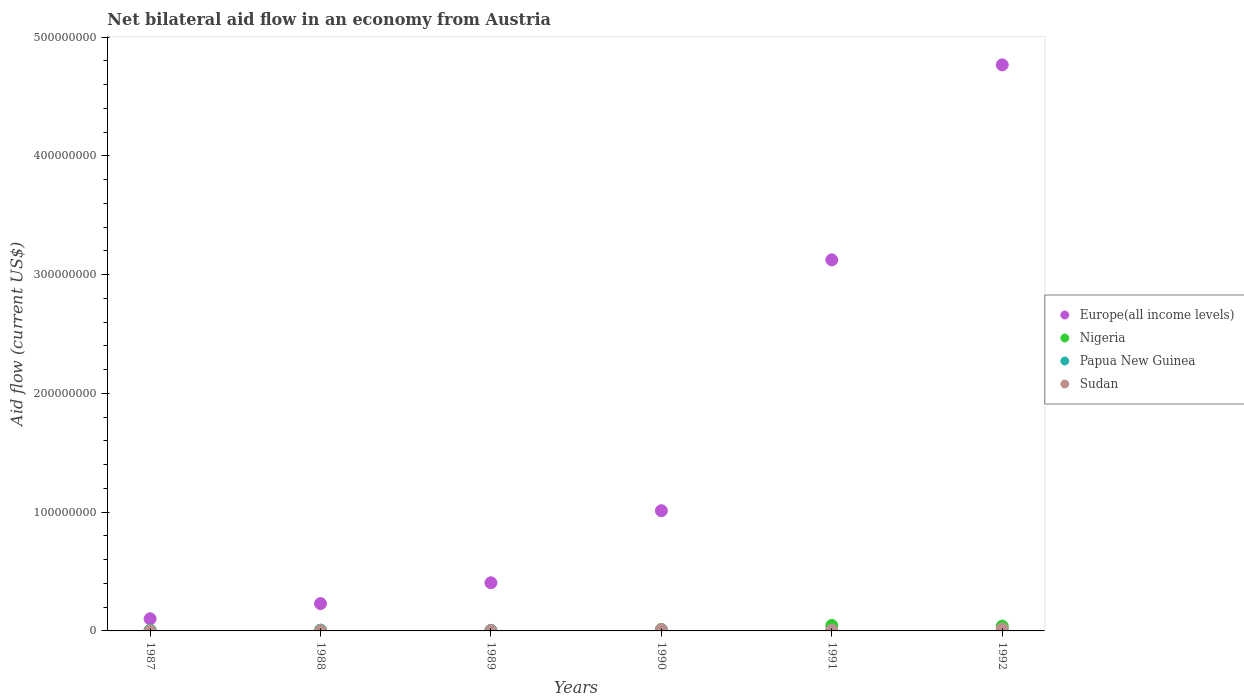How many different coloured dotlines are there?
Your answer should be very brief. 4. Is the number of dotlines equal to the number of legend labels?
Make the answer very short. Yes. What is the net bilateral aid flow in Nigeria in 1987?
Offer a terse response. 6.70e+05. Across all years, what is the maximum net bilateral aid flow in Europe(all income levels)?
Your answer should be very brief. 4.77e+08. Across all years, what is the minimum net bilateral aid flow in Papua New Guinea?
Your answer should be compact. 4.20e+05. In which year was the net bilateral aid flow in Papua New Guinea minimum?
Provide a short and direct response. 1991. What is the total net bilateral aid flow in Sudan in the graph?
Offer a terse response. 4.08e+06. What is the difference between the net bilateral aid flow in Europe(all income levels) in 1989 and the net bilateral aid flow in Nigeria in 1987?
Ensure brevity in your answer.  3.99e+07. What is the average net bilateral aid flow in Europe(all income levels) per year?
Keep it short and to the point. 1.61e+08. In the year 1990, what is the difference between the net bilateral aid flow in Sudan and net bilateral aid flow in Europe(all income levels)?
Your answer should be compact. -1.00e+08. In how many years, is the net bilateral aid flow in Europe(all income levels) greater than 340000000 US$?
Provide a short and direct response. 1. What is the ratio of the net bilateral aid flow in Sudan in 1987 to that in 1989?
Ensure brevity in your answer.  0.52. Is the net bilateral aid flow in Nigeria in 1991 less than that in 1992?
Offer a very short reply. No. Is the sum of the net bilateral aid flow in Nigeria in 1988 and 1992 greater than the maximum net bilateral aid flow in Papua New Guinea across all years?
Offer a terse response. Yes. Is it the case that in every year, the sum of the net bilateral aid flow in Sudan and net bilateral aid flow in Europe(all income levels)  is greater than the net bilateral aid flow in Nigeria?
Provide a succinct answer. Yes. Is the net bilateral aid flow in Europe(all income levels) strictly greater than the net bilateral aid flow in Nigeria over the years?
Your response must be concise. Yes. Is the net bilateral aid flow in Europe(all income levels) strictly less than the net bilateral aid flow in Papua New Guinea over the years?
Your answer should be compact. No. What is the difference between two consecutive major ticks on the Y-axis?
Provide a short and direct response. 1.00e+08. Are the values on the major ticks of Y-axis written in scientific E-notation?
Offer a terse response. No. Does the graph contain grids?
Offer a terse response. No. How many legend labels are there?
Make the answer very short. 4. What is the title of the graph?
Offer a terse response. Net bilateral aid flow in an economy from Austria. Does "Bermuda" appear as one of the legend labels in the graph?
Offer a terse response. No. What is the label or title of the X-axis?
Offer a terse response. Years. What is the label or title of the Y-axis?
Offer a very short reply. Aid flow (current US$). What is the Aid flow (current US$) in Europe(all income levels) in 1987?
Your response must be concise. 1.02e+07. What is the Aid flow (current US$) of Nigeria in 1987?
Keep it short and to the point. 6.70e+05. What is the Aid flow (current US$) in Papua New Guinea in 1987?
Offer a very short reply. 6.40e+05. What is the Aid flow (current US$) of Europe(all income levels) in 1988?
Your answer should be compact. 2.30e+07. What is the Aid flow (current US$) of Papua New Guinea in 1988?
Ensure brevity in your answer.  5.40e+05. What is the Aid flow (current US$) of Europe(all income levels) in 1989?
Your answer should be compact. 4.05e+07. What is the Aid flow (current US$) in Papua New Guinea in 1989?
Give a very brief answer. 5.20e+05. What is the Aid flow (current US$) of Europe(all income levels) in 1990?
Your answer should be very brief. 1.01e+08. What is the Aid flow (current US$) in Nigeria in 1990?
Provide a succinct answer. 1.24e+06. What is the Aid flow (current US$) of Papua New Guinea in 1990?
Keep it short and to the point. 5.70e+05. What is the Aid flow (current US$) in Sudan in 1990?
Offer a terse response. 1.15e+06. What is the Aid flow (current US$) in Europe(all income levels) in 1991?
Offer a very short reply. 3.12e+08. What is the Aid flow (current US$) of Nigeria in 1991?
Your response must be concise. 4.63e+06. What is the Aid flow (current US$) of Europe(all income levels) in 1992?
Make the answer very short. 4.77e+08. What is the Aid flow (current US$) in Nigeria in 1992?
Make the answer very short. 4.07e+06. What is the Aid flow (current US$) of Papua New Guinea in 1992?
Ensure brevity in your answer.  5.40e+05. What is the Aid flow (current US$) of Sudan in 1992?
Keep it short and to the point. 1.61e+06. Across all years, what is the maximum Aid flow (current US$) in Europe(all income levels)?
Give a very brief answer. 4.77e+08. Across all years, what is the maximum Aid flow (current US$) in Nigeria?
Your response must be concise. 4.63e+06. Across all years, what is the maximum Aid flow (current US$) of Papua New Guinea?
Your answer should be compact. 6.40e+05. Across all years, what is the maximum Aid flow (current US$) of Sudan?
Offer a very short reply. 1.61e+06. Across all years, what is the minimum Aid flow (current US$) in Europe(all income levels)?
Ensure brevity in your answer.  1.02e+07. What is the total Aid flow (current US$) of Europe(all income levels) in the graph?
Make the answer very short. 9.64e+08. What is the total Aid flow (current US$) of Nigeria in the graph?
Your answer should be very brief. 1.15e+07. What is the total Aid flow (current US$) in Papua New Guinea in the graph?
Make the answer very short. 3.23e+06. What is the total Aid flow (current US$) of Sudan in the graph?
Make the answer very short. 4.08e+06. What is the difference between the Aid flow (current US$) in Europe(all income levels) in 1987 and that in 1988?
Offer a terse response. -1.28e+07. What is the difference between the Aid flow (current US$) in Nigeria in 1987 and that in 1988?
Your response must be concise. 10000. What is the difference between the Aid flow (current US$) in Papua New Guinea in 1987 and that in 1988?
Your response must be concise. 1.00e+05. What is the difference between the Aid flow (current US$) in Europe(all income levels) in 1987 and that in 1989?
Make the answer very short. -3.03e+07. What is the difference between the Aid flow (current US$) of Sudan in 1987 and that in 1989?
Provide a succinct answer. -1.50e+05. What is the difference between the Aid flow (current US$) in Europe(all income levels) in 1987 and that in 1990?
Provide a succinct answer. -9.10e+07. What is the difference between the Aid flow (current US$) of Nigeria in 1987 and that in 1990?
Your answer should be very brief. -5.70e+05. What is the difference between the Aid flow (current US$) in Papua New Guinea in 1987 and that in 1990?
Ensure brevity in your answer.  7.00e+04. What is the difference between the Aid flow (current US$) in Sudan in 1987 and that in 1990?
Provide a succinct answer. -9.90e+05. What is the difference between the Aid flow (current US$) in Europe(all income levels) in 1987 and that in 1991?
Provide a short and direct response. -3.02e+08. What is the difference between the Aid flow (current US$) of Nigeria in 1987 and that in 1991?
Keep it short and to the point. -3.96e+06. What is the difference between the Aid flow (current US$) of Sudan in 1987 and that in 1991?
Give a very brief answer. -4.40e+05. What is the difference between the Aid flow (current US$) in Europe(all income levels) in 1987 and that in 1992?
Provide a short and direct response. -4.66e+08. What is the difference between the Aid flow (current US$) of Nigeria in 1987 and that in 1992?
Your answer should be very brief. -3.40e+06. What is the difference between the Aid flow (current US$) in Papua New Guinea in 1987 and that in 1992?
Provide a short and direct response. 1.00e+05. What is the difference between the Aid flow (current US$) of Sudan in 1987 and that in 1992?
Offer a very short reply. -1.45e+06. What is the difference between the Aid flow (current US$) of Europe(all income levels) in 1988 and that in 1989?
Your answer should be very brief. -1.75e+07. What is the difference between the Aid flow (current US$) of Nigeria in 1988 and that in 1989?
Keep it short and to the point. 4.10e+05. What is the difference between the Aid flow (current US$) of Papua New Guinea in 1988 and that in 1989?
Your answer should be compact. 2.00e+04. What is the difference between the Aid flow (current US$) of Sudan in 1988 and that in 1989?
Make the answer very short. -6.00e+04. What is the difference between the Aid flow (current US$) of Europe(all income levels) in 1988 and that in 1990?
Your answer should be very brief. -7.82e+07. What is the difference between the Aid flow (current US$) of Nigeria in 1988 and that in 1990?
Give a very brief answer. -5.80e+05. What is the difference between the Aid flow (current US$) of Sudan in 1988 and that in 1990?
Your response must be concise. -9.00e+05. What is the difference between the Aid flow (current US$) of Europe(all income levels) in 1988 and that in 1991?
Provide a succinct answer. -2.89e+08. What is the difference between the Aid flow (current US$) in Nigeria in 1988 and that in 1991?
Offer a terse response. -3.97e+06. What is the difference between the Aid flow (current US$) in Sudan in 1988 and that in 1991?
Your response must be concise. -3.50e+05. What is the difference between the Aid flow (current US$) in Europe(all income levels) in 1988 and that in 1992?
Ensure brevity in your answer.  -4.54e+08. What is the difference between the Aid flow (current US$) in Nigeria in 1988 and that in 1992?
Provide a short and direct response. -3.41e+06. What is the difference between the Aid flow (current US$) of Papua New Guinea in 1988 and that in 1992?
Make the answer very short. 0. What is the difference between the Aid flow (current US$) in Sudan in 1988 and that in 1992?
Your response must be concise. -1.36e+06. What is the difference between the Aid flow (current US$) in Europe(all income levels) in 1989 and that in 1990?
Ensure brevity in your answer.  -6.07e+07. What is the difference between the Aid flow (current US$) in Nigeria in 1989 and that in 1990?
Offer a terse response. -9.90e+05. What is the difference between the Aid flow (current US$) of Sudan in 1989 and that in 1990?
Offer a terse response. -8.40e+05. What is the difference between the Aid flow (current US$) of Europe(all income levels) in 1989 and that in 1991?
Make the answer very short. -2.72e+08. What is the difference between the Aid flow (current US$) in Nigeria in 1989 and that in 1991?
Give a very brief answer. -4.38e+06. What is the difference between the Aid flow (current US$) of Europe(all income levels) in 1989 and that in 1992?
Your response must be concise. -4.36e+08. What is the difference between the Aid flow (current US$) of Nigeria in 1989 and that in 1992?
Give a very brief answer. -3.82e+06. What is the difference between the Aid flow (current US$) in Papua New Guinea in 1989 and that in 1992?
Keep it short and to the point. -2.00e+04. What is the difference between the Aid flow (current US$) of Sudan in 1989 and that in 1992?
Give a very brief answer. -1.30e+06. What is the difference between the Aid flow (current US$) of Europe(all income levels) in 1990 and that in 1991?
Keep it short and to the point. -2.11e+08. What is the difference between the Aid flow (current US$) of Nigeria in 1990 and that in 1991?
Provide a short and direct response. -3.39e+06. What is the difference between the Aid flow (current US$) in Papua New Guinea in 1990 and that in 1991?
Offer a terse response. 1.50e+05. What is the difference between the Aid flow (current US$) of Europe(all income levels) in 1990 and that in 1992?
Make the answer very short. -3.75e+08. What is the difference between the Aid flow (current US$) in Nigeria in 1990 and that in 1992?
Your response must be concise. -2.83e+06. What is the difference between the Aid flow (current US$) of Sudan in 1990 and that in 1992?
Your answer should be very brief. -4.60e+05. What is the difference between the Aid flow (current US$) in Europe(all income levels) in 1991 and that in 1992?
Give a very brief answer. -1.64e+08. What is the difference between the Aid flow (current US$) of Nigeria in 1991 and that in 1992?
Provide a succinct answer. 5.60e+05. What is the difference between the Aid flow (current US$) of Papua New Guinea in 1991 and that in 1992?
Give a very brief answer. -1.20e+05. What is the difference between the Aid flow (current US$) in Sudan in 1991 and that in 1992?
Ensure brevity in your answer.  -1.01e+06. What is the difference between the Aid flow (current US$) in Europe(all income levels) in 1987 and the Aid flow (current US$) in Nigeria in 1988?
Give a very brief answer. 9.56e+06. What is the difference between the Aid flow (current US$) of Europe(all income levels) in 1987 and the Aid flow (current US$) of Papua New Guinea in 1988?
Provide a short and direct response. 9.68e+06. What is the difference between the Aid flow (current US$) in Europe(all income levels) in 1987 and the Aid flow (current US$) in Sudan in 1988?
Your answer should be compact. 9.97e+06. What is the difference between the Aid flow (current US$) of Nigeria in 1987 and the Aid flow (current US$) of Papua New Guinea in 1988?
Provide a succinct answer. 1.30e+05. What is the difference between the Aid flow (current US$) of Papua New Guinea in 1987 and the Aid flow (current US$) of Sudan in 1988?
Provide a succinct answer. 3.90e+05. What is the difference between the Aid flow (current US$) of Europe(all income levels) in 1987 and the Aid flow (current US$) of Nigeria in 1989?
Offer a very short reply. 9.97e+06. What is the difference between the Aid flow (current US$) in Europe(all income levels) in 1987 and the Aid flow (current US$) in Papua New Guinea in 1989?
Your answer should be very brief. 9.70e+06. What is the difference between the Aid flow (current US$) of Europe(all income levels) in 1987 and the Aid flow (current US$) of Sudan in 1989?
Provide a short and direct response. 9.91e+06. What is the difference between the Aid flow (current US$) in Nigeria in 1987 and the Aid flow (current US$) in Papua New Guinea in 1989?
Your response must be concise. 1.50e+05. What is the difference between the Aid flow (current US$) of Europe(all income levels) in 1987 and the Aid flow (current US$) of Nigeria in 1990?
Make the answer very short. 8.98e+06. What is the difference between the Aid flow (current US$) in Europe(all income levels) in 1987 and the Aid flow (current US$) in Papua New Guinea in 1990?
Offer a very short reply. 9.65e+06. What is the difference between the Aid flow (current US$) in Europe(all income levels) in 1987 and the Aid flow (current US$) in Sudan in 1990?
Make the answer very short. 9.07e+06. What is the difference between the Aid flow (current US$) in Nigeria in 1987 and the Aid flow (current US$) in Papua New Guinea in 1990?
Your answer should be very brief. 1.00e+05. What is the difference between the Aid flow (current US$) in Nigeria in 1987 and the Aid flow (current US$) in Sudan in 1990?
Make the answer very short. -4.80e+05. What is the difference between the Aid flow (current US$) in Papua New Guinea in 1987 and the Aid flow (current US$) in Sudan in 1990?
Offer a terse response. -5.10e+05. What is the difference between the Aid flow (current US$) of Europe(all income levels) in 1987 and the Aid flow (current US$) of Nigeria in 1991?
Provide a short and direct response. 5.59e+06. What is the difference between the Aid flow (current US$) in Europe(all income levels) in 1987 and the Aid flow (current US$) in Papua New Guinea in 1991?
Provide a succinct answer. 9.80e+06. What is the difference between the Aid flow (current US$) of Europe(all income levels) in 1987 and the Aid flow (current US$) of Sudan in 1991?
Give a very brief answer. 9.62e+06. What is the difference between the Aid flow (current US$) in Nigeria in 1987 and the Aid flow (current US$) in Papua New Guinea in 1991?
Your answer should be compact. 2.50e+05. What is the difference between the Aid flow (current US$) in Papua New Guinea in 1987 and the Aid flow (current US$) in Sudan in 1991?
Ensure brevity in your answer.  4.00e+04. What is the difference between the Aid flow (current US$) of Europe(all income levels) in 1987 and the Aid flow (current US$) of Nigeria in 1992?
Provide a short and direct response. 6.15e+06. What is the difference between the Aid flow (current US$) of Europe(all income levels) in 1987 and the Aid flow (current US$) of Papua New Guinea in 1992?
Give a very brief answer. 9.68e+06. What is the difference between the Aid flow (current US$) in Europe(all income levels) in 1987 and the Aid flow (current US$) in Sudan in 1992?
Provide a short and direct response. 8.61e+06. What is the difference between the Aid flow (current US$) in Nigeria in 1987 and the Aid flow (current US$) in Sudan in 1992?
Offer a terse response. -9.40e+05. What is the difference between the Aid flow (current US$) of Papua New Guinea in 1987 and the Aid flow (current US$) of Sudan in 1992?
Ensure brevity in your answer.  -9.70e+05. What is the difference between the Aid flow (current US$) in Europe(all income levels) in 1988 and the Aid flow (current US$) in Nigeria in 1989?
Keep it short and to the point. 2.28e+07. What is the difference between the Aid flow (current US$) of Europe(all income levels) in 1988 and the Aid flow (current US$) of Papua New Guinea in 1989?
Your answer should be compact. 2.25e+07. What is the difference between the Aid flow (current US$) of Europe(all income levels) in 1988 and the Aid flow (current US$) of Sudan in 1989?
Give a very brief answer. 2.27e+07. What is the difference between the Aid flow (current US$) in Europe(all income levels) in 1988 and the Aid flow (current US$) in Nigeria in 1990?
Make the answer very short. 2.18e+07. What is the difference between the Aid flow (current US$) of Europe(all income levels) in 1988 and the Aid flow (current US$) of Papua New Guinea in 1990?
Keep it short and to the point. 2.24e+07. What is the difference between the Aid flow (current US$) in Europe(all income levels) in 1988 and the Aid flow (current US$) in Sudan in 1990?
Offer a very short reply. 2.19e+07. What is the difference between the Aid flow (current US$) in Nigeria in 1988 and the Aid flow (current US$) in Sudan in 1990?
Your answer should be very brief. -4.90e+05. What is the difference between the Aid flow (current US$) of Papua New Guinea in 1988 and the Aid flow (current US$) of Sudan in 1990?
Make the answer very short. -6.10e+05. What is the difference between the Aid flow (current US$) in Europe(all income levels) in 1988 and the Aid flow (current US$) in Nigeria in 1991?
Keep it short and to the point. 1.84e+07. What is the difference between the Aid flow (current US$) in Europe(all income levels) in 1988 and the Aid flow (current US$) in Papua New Guinea in 1991?
Provide a short and direct response. 2.26e+07. What is the difference between the Aid flow (current US$) in Europe(all income levels) in 1988 and the Aid flow (current US$) in Sudan in 1991?
Ensure brevity in your answer.  2.24e+07. What is the difference between the Aid flow (current US$) of Nigeria in 1988 and the Aid flow (current US$) of Papua New Guinea in 1991?
Keep it short and to the point. 2.40e+05. What is the difference between the Aid flow (current US$) in Europe(all income levels) in 1988 and the Aid flow (current US$) in Nigeria in 1992?
Make the answer very short. 1.89e+07. What is the difference between the Aid flow (current US$) of Europe(all income levels) in 1988 and the Aid flow (current US$) of Papua New Guinea in 1992?
Your answer should be compact. 2.25e+07. What is the difference between the Aid flow (current US$) in Europe(all income levels) in 1988 and the Aid flow (current US$) in Sudan in 1992?
Your answer should be compact. 2.14e+07. What is the difference between the Aid flow (current US$) of Nigeria in 1988 and the Aid flow (current US$) of Sudan in 1992?
Make the answer very short. -9.50e+05. What is the difference between the Aid flow (current US$) in Papua New Guinea in 1988 and the Aid flow (current US$) in Sudan in 1992?
Make the answer very short. -1.07e+06. What is the difference between the Aid flow (current US$) of Europe(all income levels) in 1989 and the Aid flow (current US$) of Nigeria in 1990?
Offer a very short reply. 3.93e+07. What is the difference between the Aid flow (current US$) of Europe(all income levels) in 1989 and the Aid flow (current US$) of Papua New Guinea in 1990?
Offer a terse response. 4.00e+07. What is the difference between the Aid flow (current US$) of Europe(all income levels) in 1989 and the Aid flow (current US$) of Sudan in 1990?
Offer a very short reply. 3.94e+07. What is the difference between the Aid flow (current US$) in Nigeria in 1989 and the Aid flow (current US$) in Papua New Guinea in 1990?
Offer a very short reply. -3.20e+05. What is the difference between the Aid flow (current US$) in Nigeria in 1989 and the Aid flow (current US$) in Sudan in 1990?
Your answer should be compact. -9.00e+05. What is the difference between the Aid flow (current US$) in Papua New Guinea in 1989 and the Aid flow (current US$) in Sudan in 1990?
Keep it short and to the point. -6.30e+05. What is the difference between the Aid flow (current US$) of Europe(all income levels) in 1989 and the Aid flow (current US$) of Nigeria in 1991?
Your answer should be compact. 3.59e+07. What is the difference between the Aid flow (current US$) of Europe(all income levels) in 1989 and the Aid flow (current US$) of Papua New Guinea in 1991?
Offer a terse response. 4.01e+07. What is the difference between the Aid flow (current US$) of Europe(all income levels) in 1989 and the Aid flow (current US$) of Sudan in 1991?
Your response must be concise. 3.99e+07. What is the difference between the Aid flow (current US$) of Nigeria in 1989 and the Aid flow (current US$) of Sudan in 1991?
Make the answer very short. -3.50e+05. What is the difference between the Aid flow (current US$) in Papua New Guinea in 1989 and the Aid flow (current US$) in Sudan in 1991?
Offer a very short reply. -8.00e+04. What is the difference between the Aid flow (current US$) in Europe(all income levels) in 1989 and the Aid flow (current US$) in Nigeria in 1992?
Provide a short and direct response. 3.65e+07. What is the difference between the Aid flow (current US$) in Europe(all income levels) in 1989 and the Aid flow (current US$) in Papua New Guinea in 1992?
Keep it short and to the point. 4.00e+07. What is the difference between the Aid flow (current US$) in Europe(all income levels) in 1989 and the Aid flow (current US$) in Sudan in 1992?
Your response must be concise. 3.89e+07. What is the difference between the Aid flow (current US$) of Nigeria in 1989 and the Aid flow (current US$) of Sudan in 1992?
Offer a very short reply. -1.36e+06. What is the difference between the Aid flow (current US$) in Papua New Guinea in 1989 and the Aid flow (current US$) in Sudan in 1992?
Offer a very short reply. -1.09e+06. What is the difference between the Aid flow (current US$) of Europe(all income levels) in 1990 and the Aid flow (current US$) of Nigeria in 1991?
Provide a short and direct response. 9.66e+07. What is the difference between the Aid flow (current US$) in Europe(all income levels) in 1990 and the Aid flow (current US$) in Papua New Guinea in 1991?
Your response must be concise. 1.01e+08. What is the difference between the Aid flow (current US$) of Europe(all income levels) in 1990 and the Aid flow (current US$) of Sudan in 1991?
Your answer should be compact. 1.01e+08. What is the difference between the Aid flow (current US$) of Nigeria in 1990 and the Aid flow (current US$) of Papua New Guinea in 1991?
Offer a very short reply. 8.20e+05. What is the difference between the Aid flow (current US$) of Nigeria in 1990 and the Aid flow (current US$) of Sudan in 1991?
Your answer should be very brief. 6.40e+05. What is the difference between the Aid flow (current US$) of Europe(all income levels) in 1990 and the Aid flow (current US$) of Nigeria in 1992?
Offer a very short reply. 9.71e+07. What is the difference between the Aid flow (current US$) in Europe(all income levels) in 1990 and the Aid flow (current US$) in Papua New Guinea in 1992?
Provide a succinct answer. 1.01e+08. What is the difference between the Aid flow (current US$) in Europe(all income levels) in 1990 and the Aid flow (current US$) in Sudan in 1992?
Your answer should be very brief. 9.96e+07. What is the difference between the Aid flow (current US$) in Nigeria in 1990 and the Aid flow (current US$) in Papua New Guinea in 1992?
Provide a short and direct response. 7.00e+05. What is the difference between the Aid flow (current US$) in Nigeria in 1990 and the Aid flow (current US$) in Sudan in 1992?
Provide a short and direct response. -3.70e+05. What is the difference between the Aid flow (current US$) in Papua New Guinea in 1990 and the Aid flow (current US$) in Sudan in 1992?
Give a very brief answer. -1.04e+06. What is the difference between the Aid flow (current US$) of Europe(all income levels) in 1991 and the Aid flow (current US$) of Nigeria in 1992?
Your answer should be very brief. 3.08e+08. What is the difference between the Aid flow (current US$) in Europe(all income levels) in 1991 and the Aid flow (current US$) in Papua New Guinea in 1992?
Offer a very short reply. 3.12e+08. What is the difference between the Aid flow (current US$) of Europe(all income levels) in 1991 and the Aid flow (current US$) of Sudan in 1992?
Ensure brevity in your answer.  3.11e+08. What is the difference between the Aid flow (current US$) of Nigeria in 1991 and the Aid flow (current US$) of Papua New Guinea in 1992?
Your response must be concise. 4.09e+06. What is the difference between the Aid flow (current US$) of Nigeria in 1991 and the Aid flow (current US$) of Sudan in 1992?
Make the answer very short. 3.02e+06. What is the difference between the Aid flow (current US$) in Papua New Guinea in 1991 and the Aid flow (current US$) in Sudan in 1992?
Your response must be concise. -1.19e+06. What is the average Aid flow (current US$) of Europe(all income levels) per year?
Offer a very short reply. 1.61e+08. What is the average Aid flow (current US$) of Nigeria per year?
Provide a succinct answer. 1.92e+06. What is the average Aid flow (current US$) of Papua New Guinea per year?
Ensure brevity in your answer.  5.38e+05. What is the average Aid flow (current US$) of Sudan per year?
Keep it short and to the point. 6.80e+05. In the year 1987, what is the difference between the Aid flow (current US$) in Europe(all income levels) and Aid flow (current US$) in Nigeria?
Ensure brevity in your answer.  9.55e+06. In the year 1987, what is the difference between the Aid flow (current US$) in Europe(all income levels) and Aid flow (current US$) in Papua New Guinea?
Offer a very short reply. 9.58e+06. In the year 1987, what is the difference between the Aid flow (current US$) in Europe(all income levels) and Aid flow (current US$) in Sudan?
Your response must be concise. 1.01e+07. In the year 1987, what is the difference between the Aid flow (current US$) of Nigeria and Aid flow (current US$) of Sudan?
Offer a very short reply. 5.10e+05. In the year 1987, what is the difference between the Aid flow (current US$) in Papua New Guinea and Aid flow (current US$) in Sudan?
Ensure brevity in your answer.  4.80e+05. In the year 1988, what is the difference between the Aid flow (current US$) of Europe(all income levels) and Aid flow (current US$) of Nigeria?
Provide a succinct answer. 2.24e+07. In the year 1988, what is the difference between the Aid flow (current US$) in Europe(all income levels) and Aid flow (current US$) in Papua New Guinea?
Provide a short and direct response. 2.25e+07. In the year 1988, what is the difference between the Aid flow (current US$) in Europe(all income levels) and Aid flow (current US$) in Sudan?
Offer a very short reply. 2.28e+07. In the year 1988, what is the difference between the Aid flow (current US$) of Nigeria and Aid flow (current US$) of Papua New Guinea?
Offer a terse response. 1.20e+05. In the year 1988, what is the difference between the Aid flow (current US$) in Nigeria and Aid flow (current US$) in Sudan?
Keep it short and to the point. 4.10e+05. In the year 1988, what is the difference between the Aid flow (current US$) in Papua New Guinea and Aid flow (current US$) in Sudan?
Offer a terse response. 2.90e+05. In the year 1989, what is the difference between the Aid flow (current US$) of Europe(all income levels) and Aid flow (current US$) of Nigeria?
Give a very brief answer. 4.03e+07. In the year 1989, what is the difference between the Aid flow (current US$) in Europe(all income levels) and Aid flow (current US$) in Papua New Guinea?
Give a very brief answer. 4.00e+07. In the year 1989, what is the difference between the Aid flow (current US$) of Europe(all income levels) and Aid flow (current US$) of Sudan?
Your answer should be very brief. 4.02e+07. In the year 1989, what is the difference between the Aid flow (current US$) in Nigeria and Aid flow (current US$) in Sudan?
Provide a succinct answer. -6.00e+04. In the year 1989, what is the difference between the Aid flow (current US$) in Papua New Guinea and Aid flow (current US$) in Sudan?
Give a very brief answer. 2.10e+05. In the year 1990, what is the difference between the Aid flow (current US$) of Europe(all income levels) and Aid flow (current US$) of Nigeria?
Your response must be concise. 1.00e+08. In the year 1990, what is the difference between the Aid flow (current US$) in Europe(all income levels) and Aid flow (current US$) in Papua New Guinea?
Provide a succinct answer. 1.01e+08. In the year 1990, what is the difference between the Aid flow (current US$) of Europe(all income levels) and Aid flow (current US$) of Sudan?
Your response must be concise. 1.00e+08. In the year 1990, what is the difference between the Aid flow (current US$) in Nigeria and Aid flow (current US$) in Papua New Guinea?
Your answer should be compact. 6.70e+05. In the year 1990, what is the difference between the Aid flow (current US$) of Papua New Guinea and Aid flow (current US$) of Sudan?
Keep it short and to the point. -5.80e+05. In the year 1991, what is the difference between the Aid flow (current US$) of Europe(all income levels) and Aid flow (current US$) of Nigeria?
Give a very brief answer. 3.08e+08. In the year 1991, what is the difference between the Aid flow (current US$) of Europe(all income levels) and Aid flow (current US$) of Papua New Guinea?
Your response must be concise. 3.12e+08. In the year 1991, what is the difference between the Aid flow (current US$) of Europe(all income levels) and Aid flow (current US$) of Sudan?
Ensure brevity in your answer.  3.12e+08. In the year 1991, what is the difference between the Aid flow (current US$) of Nigeria and Aid flow (current US$) of Papua New Guinea?
Ensure brevity in your answer.  4.21e+06. In the year 1991, what is the difference between the Aid flow (current US$) in Nigeria and Aid flow (current US$) in Sudan?
Offer a terse response. 4.03e+06. In the year 1992, what is the difference between the Aid flow (current US$) of Europe(all income levels) and Aid flow (current US$) of Nigeria?
Offer a terse response. 4.73e+08. In the year 1992, what is the difference between the Aid flow (current US$) of Europe(all income levels) and Aid flow (current US$) of Papua New Guinea?
Make the answer very short. 4.76e+08. In the year 1992, what is the difference between the Aid flow (current US$) in Europe(all income levels) and Aid flow (current US$) in Sudan?
Keep it short and to the point. 4.75e+08. In the year 1992, what is the difference between the Aid flow (current US$) in Nigeria and Aid flow (current US$) in Papua New Guinea?
Your response must be concise. 3.53e+06. In the year 1992, what is the difference between the Aid flow (current US$) in Nigeria and Aid flow (current US$) in Sudan?
Give a very brief answer. 2.46e+06. In the year 1992, what is the difference between the Aid flow (current US$) in Papua New Guinea and Aid flow (current US$) in Sudan?
Provide a succinct answer. -1.07e+06. What is the ratio of the Aid flow (current US$) of Europe(all income levels) in 1987 to that in 1988?
Give a very brief answer. 0.44. What is the ratio of the Aid flow (current US$) of Nigeria in 1987 to that in 1988?
Offer a very short reply. 1.02. What is the ratio of the Aid flow (current US$) in Papua New Guinea in 1987 to that in 1988?
Offer a very short reply. 1.19. What is the ratio of the Aid flow (current US$) in Sudan in 1987 to that in 1988?
Offer a terse response. 0.64. What is the ratio of the Aid flow (current US$) in Europe(all income levels) in 1987 to that in 1989?
Provide a succinct answer. 0.25. What is the ratio of the Aid flow (current US$) of Nigeria in 1987 to that in 1989?
Make the answer very short. 2.68. What is the ratio of the Aid flow (current US$) of Papua New Guinea in 1987 to that in 1989?
Your answer should be compact. 1.23. What is the ratio of the Aid flow (current US$) in Sudan in 1987 to that in 1989?
Keep it short and to the point. 0.52. What is the ratio of the Aid flow (current US$) in Europe(all income levels) in 1987 to that in 1990?
Keep it short and to the point. 0.1. What is the ratio of the Aid flow (current US$) in Nigeria in 1987 to that in 1990?
Your answer should be very brief. 0.54. What is the ratio of the Aid flow (current US$) of Papua New Guinea in 1987 to that in 1990?
Ensure brevity in your answer.  1.12. What is the ratio of the Aid flow (current US$) in Sudan in 1987 to that in 1990?
Your answer should be compact. 0.14. What is the ratio of the Aid flow (current US$) of Europe(all income levels) in 1987 to that in 1991?
Provide a succinct answer. 0.03. What is the ratio of the Aid flow (current US$) of Nigeria in 1987 to that in 1991?
Ensure brevity in your answer.  0.14. What is the ratio of the Aid flow (current US$) in Papua New Guinea in 1987 to that in 1991?
Offer a terse response. 1.52. What is the ratio of the Aid flow (current US$) of Sudan in 1987 to that in 1991?
Keep it short and to the point. 0.27. What is the ratio of the Aid flow (current US$) in Europe(all income levels) in 1987 to that in 1992?
Your answer should be very brief. 0.02. What is the ratio of the Aid flow (current US$) in Nigeria in 1987 to that in 1992?
Ensure brevity in your answer.  0.16. What is the ratio of the Aid flow (current US$) in Papua New Guinea in 1987 to that in 1992?
Ensure brevity in your answer.  1.19. What is the ratio of the Aid flow (current US$) in Sudan in 1987 to that in 1992?
Provide a succinct answer. 0.1. What is the ratio of the Aid flow (current US$) in Europe(all income levels) in 1988 to that in 1989?
Your response must be concise. 0.57. What is the ratio of the Aid flow (current US$) of Nigeria in 1988 to that in 1989?
Your response must be concise. 2.64. What is the ratio of the Aid flow (current US$) of Papua New Guinea in 1988 to that in 1989?
Your answer should be compact. 1.04. What is the ratio of the Aid flow (current US$) of Sudan in 1988 to that in 1989?
Your response must be concise. 0.81. What is the ratio of the Aid flow (current US$) in Europe(all income levels) in 1988 to that in 1990?
Your answer should be compact. 0.23. What is the ratio of the Aid flow (current US$) in Nigeria in 1988 to that in 1990?
Provide a short and direct response. 0.53. What is the ratio of the Aid flow (current US$) in Sudan in 1988 to that in 1990?
Make the answer very short. 0.22. What is the ratio of the Aid flow (current US$) of Europe(all income levels) in 1988 to that in 1991?
Your response must be concise. 0.07. What is the ratio of the Aid flow (current US$) in Nigeria in 1988 to that in 1991?
Provide a succinct answer. 0.14. What is the ratio of the Aid flow (current US$) of Papua New Guinea in 1988 to that in 1991?
Your answer should be very brief. 1.29. What is the ratio of the Aid flow (current US$) of Sudan in 1988 to that in 1991?
Offer a very short reply. 0.42. What is the ratio of the Aid flow (current US$) of Europe(all income levels) in 1988 to that in 1992?
Offer a terse response. 0.05. What is the ratio of the Aid flow (current US$) of Nigeria in 1988 to that in 1992?
Ensure brevity in your answer.  0.16. What is the ratio of the Aid flow (current US$) of Papua New Guinea in 1988 to that in 1992?
Keep it short and to the point. 1. What is the ratio of the Aid flow (current US$) in Sudan in 1988 to that in 1992?
Ensure brevity in your answer.  0.16. What is the ratio of the Aid flow (current US$) in Europe(all income levels) in 1989 to that in 1990?
Offer a terse response. 0.4. What is the ratio of the Aid flow (current US$) in Nigeria in 1989 to that in 1990?
Your response must be concise. 0.2. What is the ratio of the Aid flow (current US$) of Papua New Guinea in 1989 to that in 1990?
Provide a succinct answer. 0.91. What is the ratio of the Aid flow (current US$) of Sudan in 1989 to that in 1990?
Your response must be concise. 0.27. What is the ratio of the Aid flow (current US$) of Europe(all income levels) in 1989 to that in 1991?
Give a very brief answer. 0.13. What is the ratio of the Aid flow (current US$) of Nigeria in 1989 to that in 1991?
Provide a short and direct response. 0.05. What is the ratio of the Aid flow (current US$) of Papua New Guinea in 1989 to that in 1991?
Your answer should be very brief. 1.24. What is the ratio of the Aid flow (current US$) in Sudan in 1989 to that in 1991?
Your response must be concise. 0.52. What is the ratio of the Aid flow (current US$) of Europe(all income levels) in 1989 to that in 1992?
Make the answer very short. 0.09. What is the ratio of the Aid flow (current US$) of Nigeria in 1989 to that in 1992?
Offer a very short reply. 0.06. What is the ratio of the Aid flow (current US$) in Papua New Guinea in 1989 to that in 1992?
Ensure brevity in your answer.  0.96. What is the ratio of the Aid flow (current US$) of Sudan in 1989 to that in 1992?
Offer a very short reply. 0.19. What is the ratio of the Aid flow (current US$) in Europe(all income levels) in 1990 to that in 1991?
Ensure brevity in your answer.  0.32. What is the ratio of the Aid flow (current US$) in Nigeria in 1990 to that in 1991?
Make the answer very short. 0.27. What is the ratio of the Aid flow (current US$) of Papua New Guinea in 1990 to that in 1991?
Provide a short and direct response. 1.36. What is the ratio of the Aid flow (current US$) in Sudan in 1990 to that in 1991?
Ensure brevity in your answer.  1.92. What is the ratio of the Aid flow (current US$) of Europe(all income levels) in 1990 to that in 1992?
Make the answer very short. 0.21. What is the ratio of the Aid flow (current US$) in Nigeria in 1990 to that in 1992?
Make the answer very short. 0.3. What is the ratio of the Aid flow (current US$) of Papua New Guinea in 1990 to that in 1992?
Offer a very short reply. 1.06. What is the ratio of the Aid flow (current US$) of Europe(all income levels) in 1991 to that in 1992?
Your answer should be compact. 0.66. What is the ratio of the Aid flow (current US$) in Nigeria in 1991 to that in 1992?
Make the answer very short. 1.14. What is the ratio of the Aid flow (current US$) in Papua New Guinea in 1991 to that in 1992?
Make the answer very short. 0.78. What is the ratio of the Aid flow (current US$) of Sudan in 1991 to that in 1992?
Your response must be concise. 0.37. What is the difference between the highest and the second highest Aid flow (current US$) in Europe(all income levels)?
Keep it short and to the point. 1.64e+08. What is the difference between the highest and the second highest Aid flow (current US$) in Nigeria?
Make the answer very short. 5.60e+05. What is the difference between the highest and the second highest Aid flow (current US$) of Papua New Guinea?
Your answer should be compact. 7.00e+04. What is the difference between the highest and the lowest Aid flow (current US$) in Europe(all income levels)?
Provide a short and direct response. 4.66e+08. What is the difference between the highest and the lowest Aid flow (current US$) in Nigeria?
Your response must be concise. 4.38e+06. What is the difference between the highest and the lowest Aid flow (current US$) in Sudan?
Give a very brief answer. 1.45e+06. 